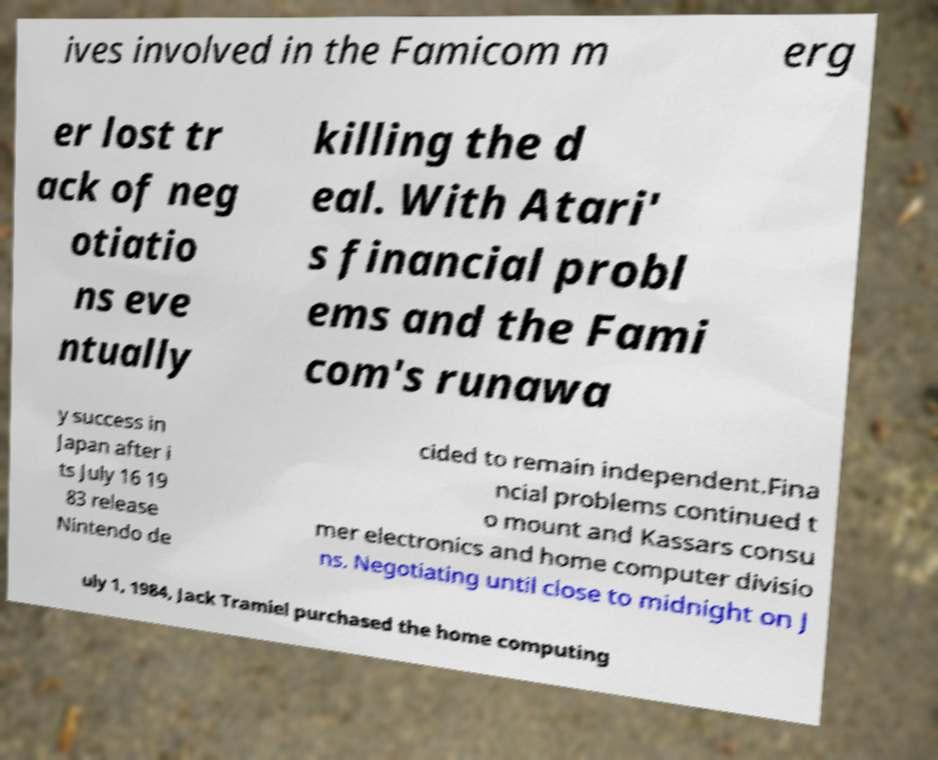Please identify and transcribe the text found in this image. ives involved in the Famicom m erg er lost tr ack of neg otiatio ns eve ntually killing the d eal. With Atari' s financial probl ems and the Fami com's runawa y success in Japan after i ts July 16 19 83 release Nintendo de cided to remain independent.Fina ncial problems continued t o mount and Kassars consu mer electronics and home computer divisio ns. Negotiating until close to midnight on J uly 1, 1984, Jack Tramiel purchased the home computing 